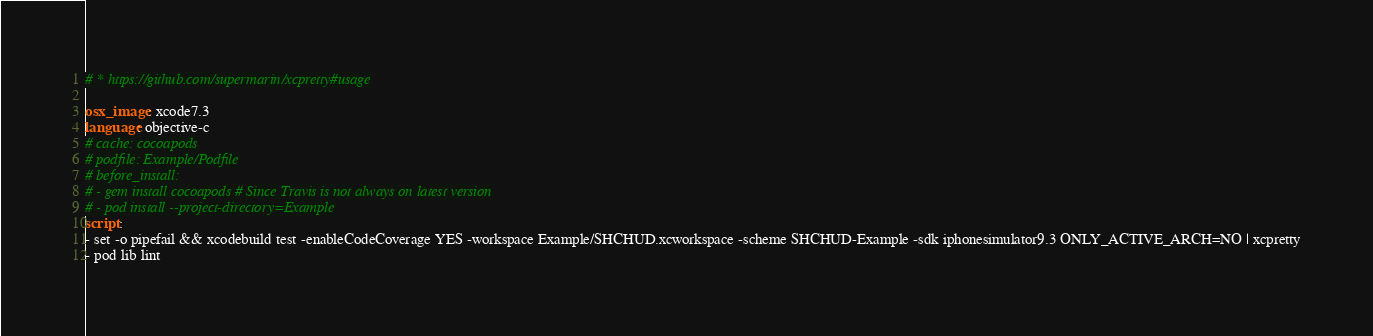Convert code to text. <code><loc_0><loc_0><loc_500><loc_500><_YAML_># * https://github.com/supermarin/xcpretty#usage

osx_image: xcode7.3
language: objective-c
# cache: cocoapods
# podfile: Example/Podfile
# before_install:
# - gem install cocoapods # Since Travis is not always on latest version
# - pod install --project-directory=Example
script:
- set -o pipefail && xcodebuild test -enableCodeCoverage YES -workspace Example/SHCHUD.xcworkspace -scheme SHCHUD-Example -sdk iphonesimulator9.3 ONLY_ACTIVE_ARCH=NO | xcpretty
- pod lib lint
</code> 